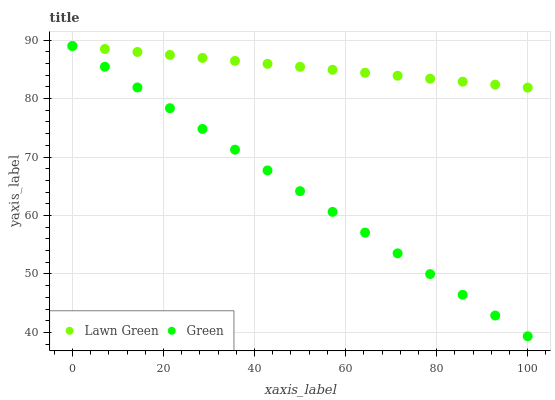Does Green have the minimum area under the curve?
Answer yes or no. Yes. Does Lawn Green have the maximum area under the curve?
Answer yes or no. Yes. Does Green have the maximum area under the curve?
Answer yes or no. No. Is Green the smoothest?
Answer yes or no. Yes. Is Lawn Green the roughest?
Answer yes or no. Yes. Is Green the roughest?
Answer yes or no. No. Does Green have the lowest value?
Answer yes or no. Yes. Does Green have the highest value?
Answer yes or no. Yes. Does Green intersect Lawn Green?
Answer yes or no. Yes. Is Green less than Lawn Green?
Answer yes or no. No. Is Green greater than Lawn Green?
Answer yes or no. No. 